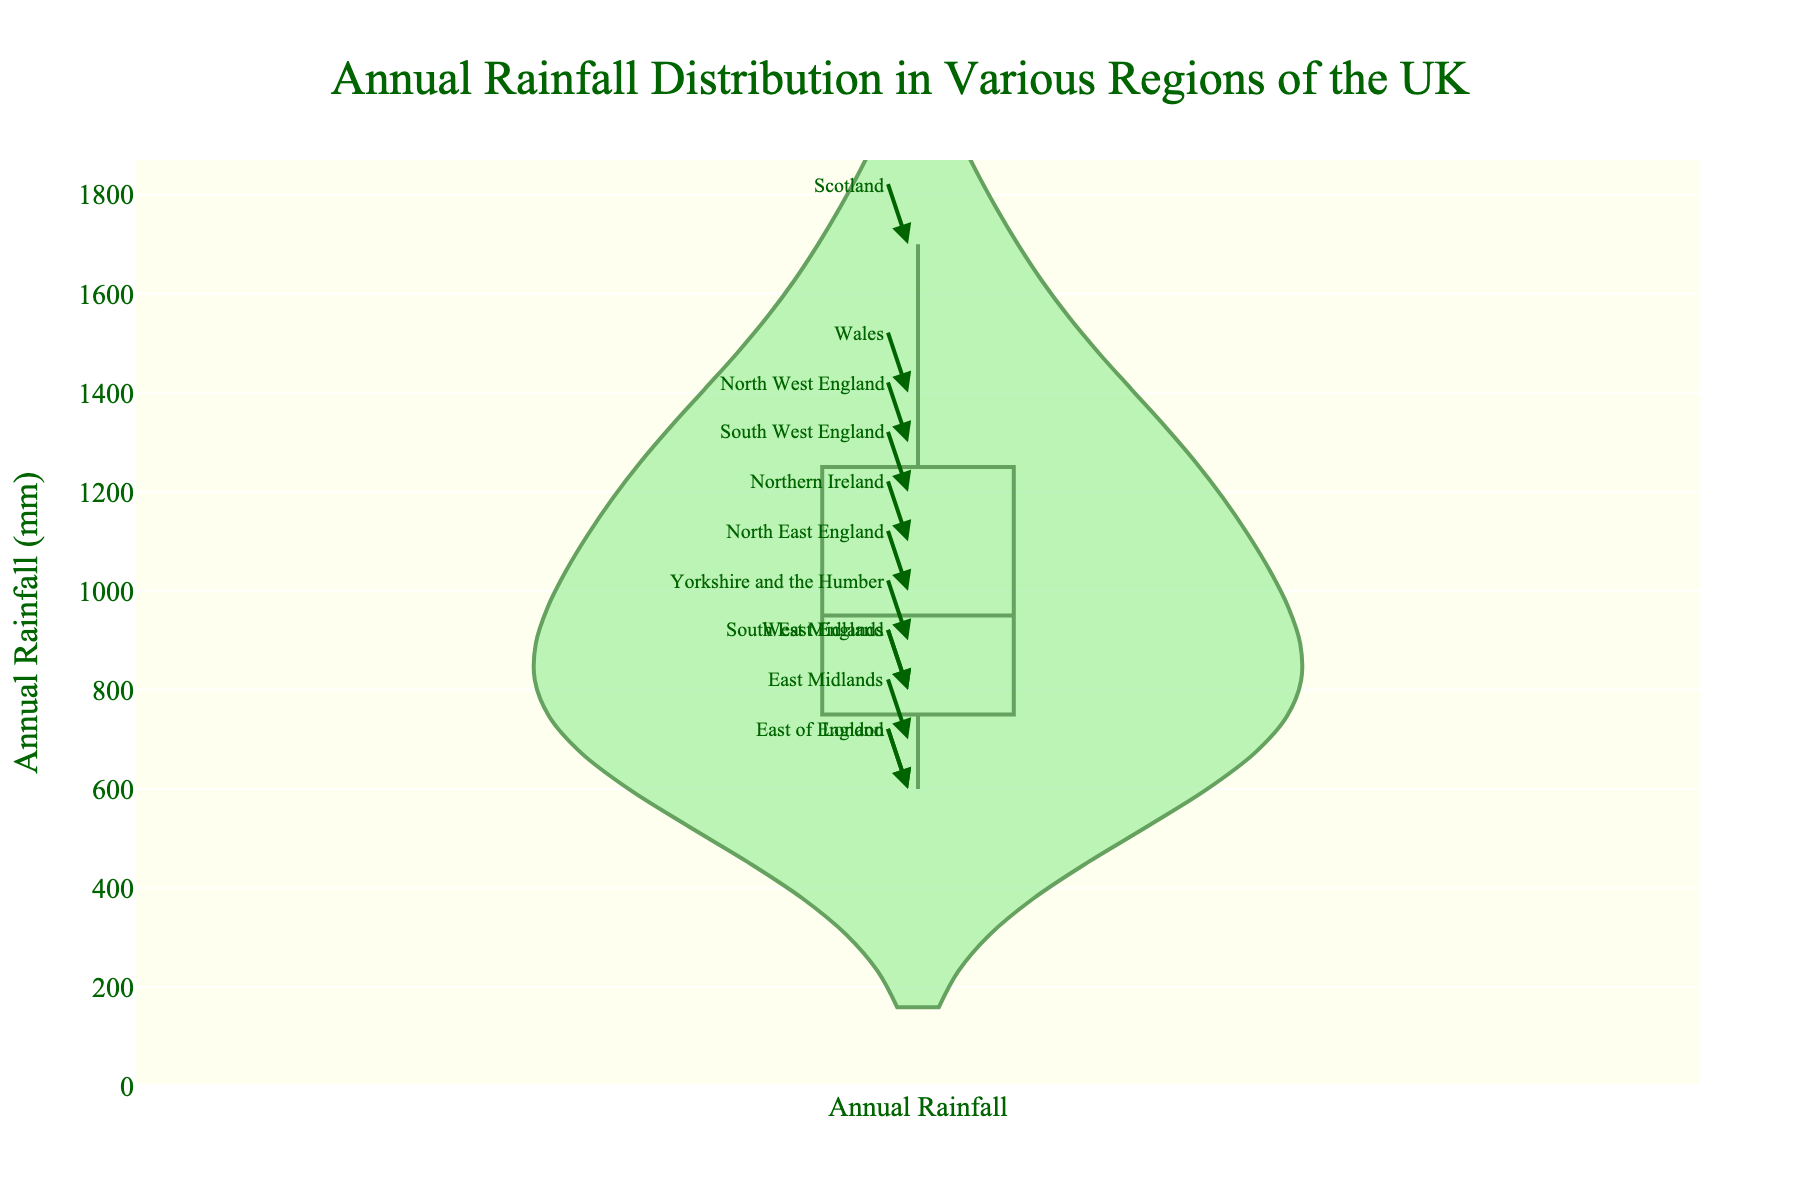What is the title of the plot? The title is located at the top center of the plot, it states the main subject.
Answer: "Annual Rainfall Distribution in Various Regions of the UK" What region has the highest annual rainfall according to the plot? Check the annotation arrow pointing to the highest value on the y-axis, which will indicate the region with maximum rainfall.
Answer: Scotland How many regions have an annual rainfall of 1,000 mm or more? Identify all labeled points on the y-axis at or above the 1,000 mm mark and count them.
Answer: 6 regions Which region has the least annual rainfall? Check the annotation arrow pointing to the lowest value on the y-axis, which will indicate the region with minimum rainfall.
Answer: East of England and London What is the range of annual rainfall values displayed in the plot? Determine the difference between the highest value and the lowest value on the y-axis.
Answer: 1,100 mm What is the average annual rainfall across all regions? Sum all the annual rainfall values given and divide by the number of regions.
Answer: 1,013 mm Which has more rainfall, North East England or South East England? Compare the y-axis values annotated next to "North East England" and "South East England".
Answer: North East England How does the rainfall in Wales compare to Northern Ireland? Find and compare the y-axis values annotated next to "Wales" and "Northern Ireland".
Answer: Wales has more rainfall What is the difference in annual rainfall between the region with the most and the least rainfall? Identify the highest and lowest y-axis values, then subtract the lowest from the highest.
Answer: 1,100 mm Which regions have an annual rainfall of 800 mm? Identify all annotated points on the y-axis at the 800 mm mark and list the associated regions.
Answer: South East England, West Midlands 